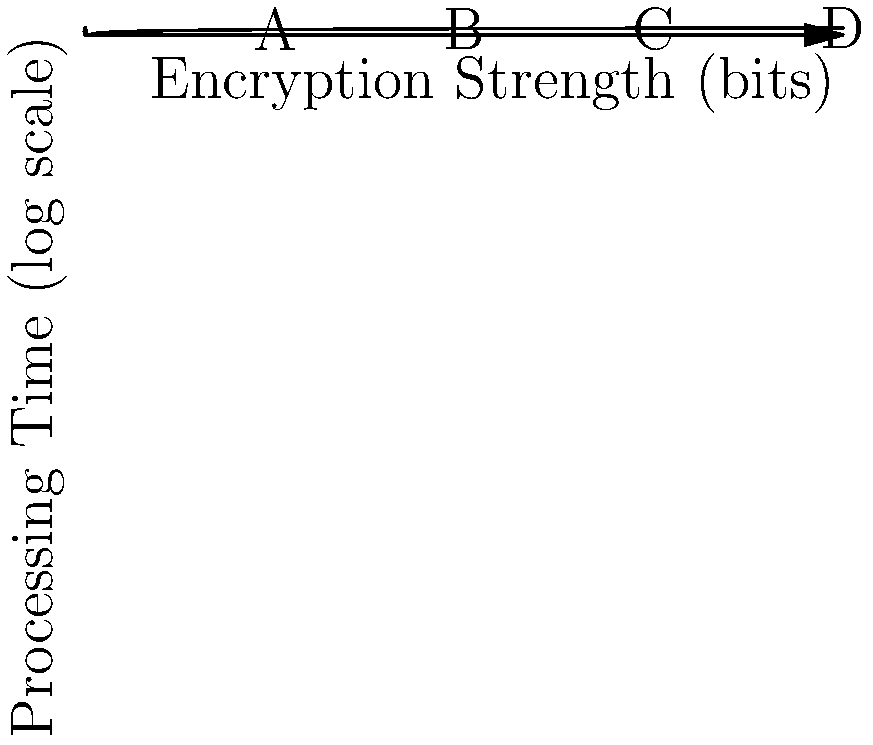In the logarithmic scale graph representing the relationship between encryption strength and processing time, points A, B, C, and D correspond to encryption strengths of 64, 128, 192, and 256 bits respectively. If the processing time for 64-bit encryption is 1 second, what is the approximate processing time for 256-bit encryption? Let's approach this step-by-step:

1) The y-axis represents the logarithm (base 10) of processing time.
2) For 64-bit encryption (point A), the processing time is 1 second. So, $\log_{10}(1) = 0$
3) The graph shows a linear relationship between encryption strength and log(processing time).
4) From 64 bits to 256 bits, the encryption strength increases by a factor of 4 (256/64 = 4).
5) In a logarithmic scale, multiplying the input by a constant adds a constant to the output.
6) So, the difference in y-values between A and D is $\log_{10}(4) \approx 0.6$
7) Therefore, the y-value at D is approximately 0.6
8) To get the actual processing time, we need to calculate $10^{0.6} \approx 4$

Thus, the processing time for 256-bit encryption is approximately 4 seconds.
Answer: 4 seconds 